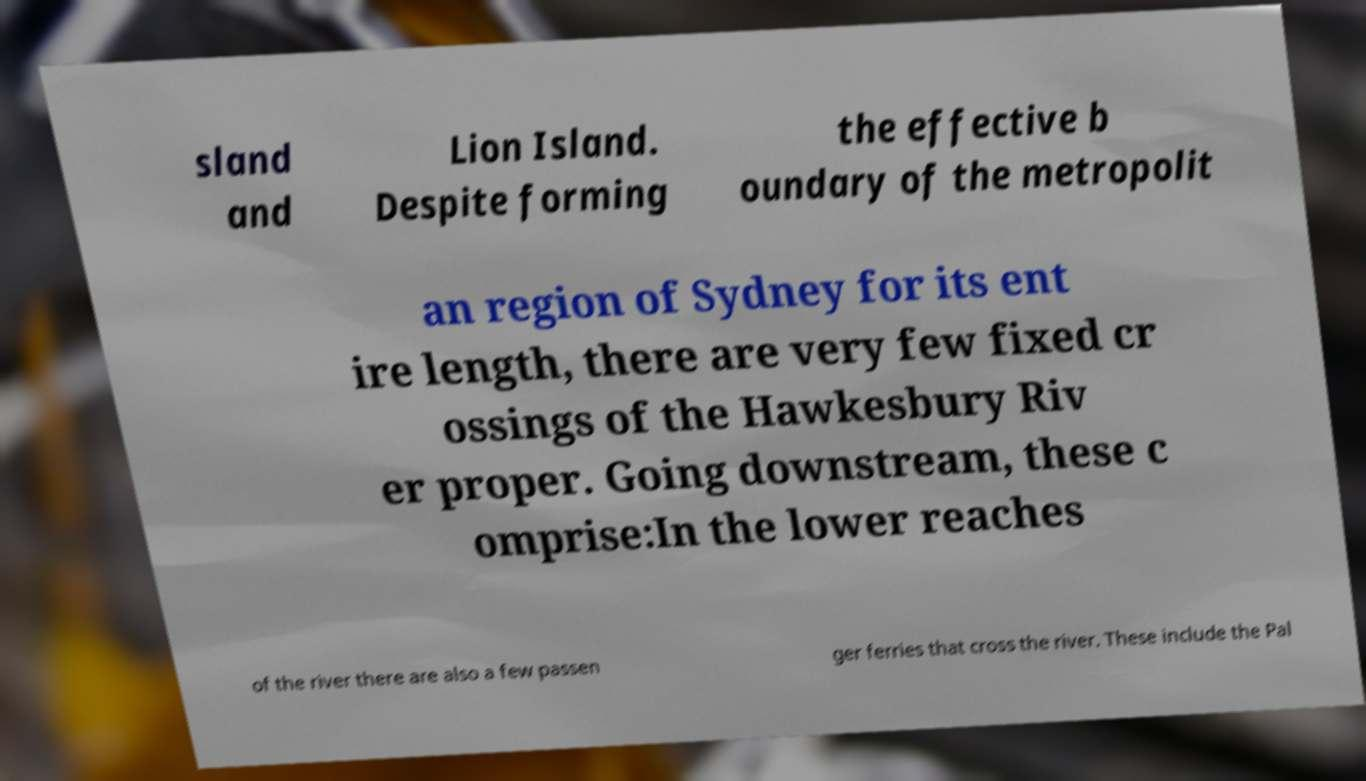Please identify and transcribe the text found in this image. sland and Lion Island. Despite forming the effective b oundary of the metropolit an region of Sydney for its ent ire length, there are very few fixed cr ossings of the Hawkesbury Riv er proper. Going downstream, these c omprise:In the lower reaches of the river there are also a few passen ger ferries that cross the river. These include the Pal 